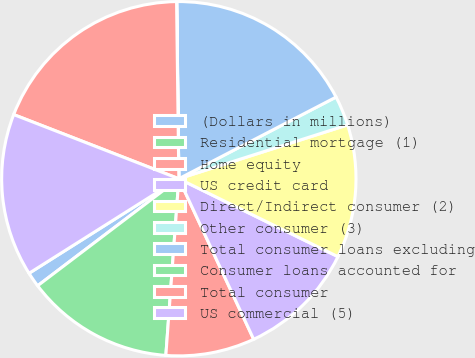Convert chart to OTSL. <chart><loc_0><loc_0><loc_500><loc_500><pie_chart><fcel>(Dollars in millions)<fcel>Residential mortgage (1)<fcel>Home equity<fcel>US credit card<fcel>Direct/Indirect consumer (2)<fcel>Other consumer (3)<fcel>Total consumer loans excluding<fcel>Consumer loans accounted for<fcel>Total consumer<fcel>US commercial (5)<nl><fcel>1.36%<fcel>13.51%<fcel>8.11%<fcel>10.81%<fcel>12.16%<fcel>2.71%<fcel>17.56%<fcel>0.02%<fcel>18.9%<fcel>14.86%<nl></chart> 